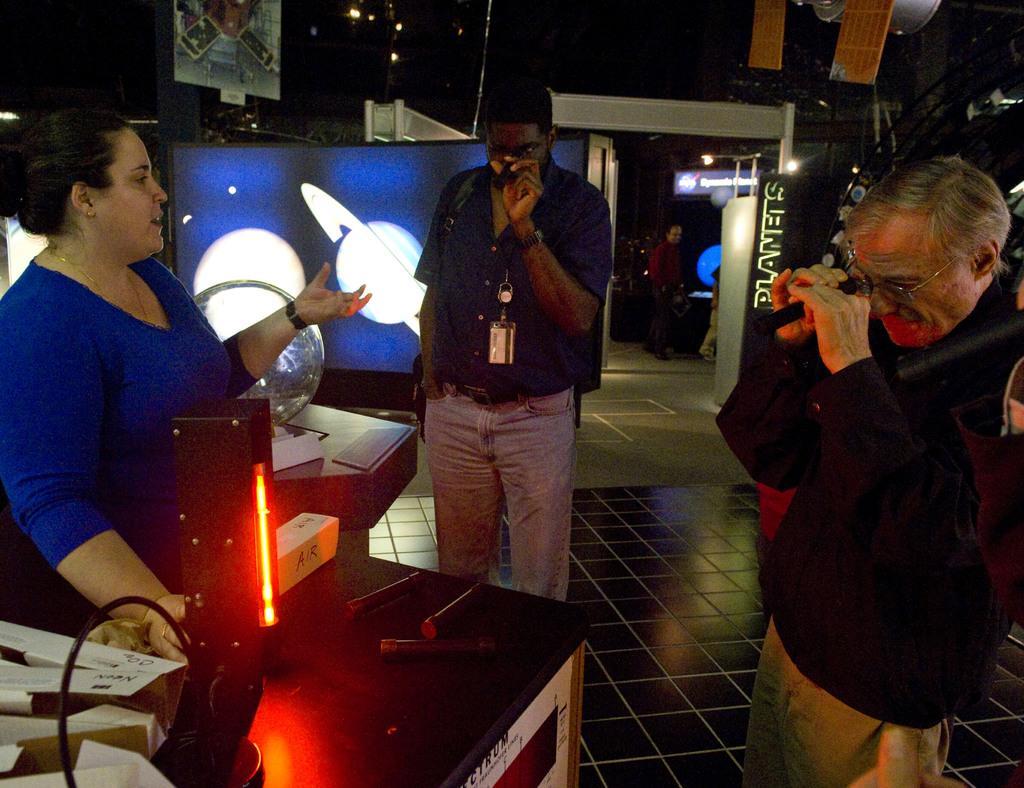Can you describe this image briefly? In this image we can see people standing on the floor. We can see globe and somethings in the background. 